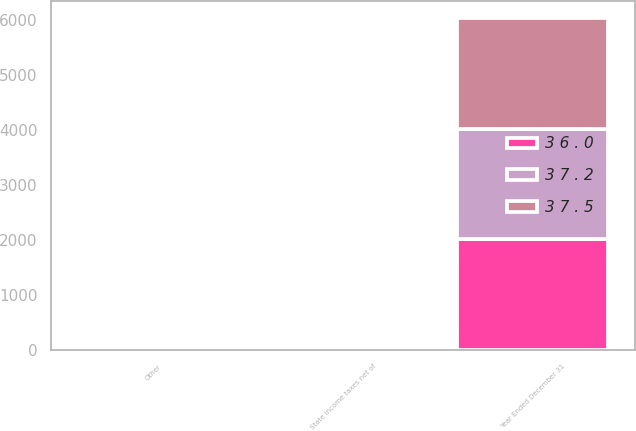Convert chart to OTSL. <chart><loc_0><loc_0><loc_500><loc_500><stacked_bar_chart><ecel><fcel>Year Ended December 31<fcel>State income taxes net of<fcel>Other<nl><fcel>3 7 . 2<fcel>2014<fcel>2.3<fcel>0.2<nl><fcel>3 7 . 5<fcel>2013<fcel>2.3<fcel>0.1<nl><fcel>3 6 . 0<fcel>2012<fcel>1.2<fcel>0.2<nl></chart> 